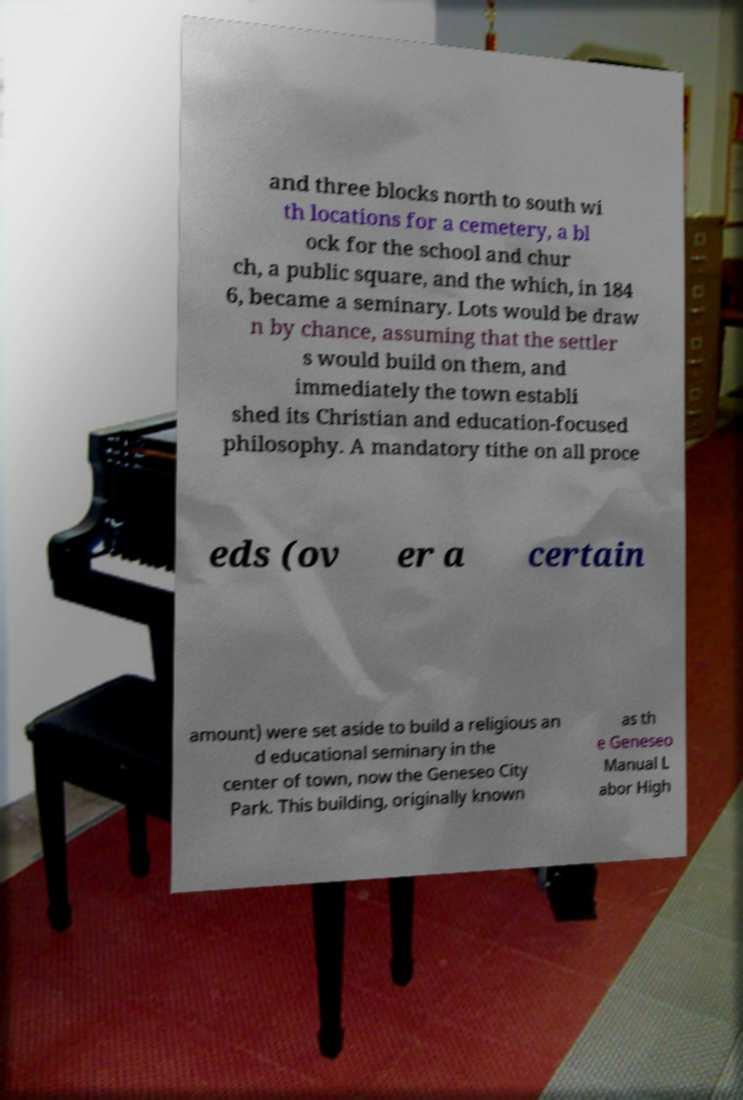Can you accurately transcribe the text from the provided image for me? and three blocks north to south wi th locations for a cemetery, a bl ock for the school and chur ch, a public square, and the which, in 184 6, became a seminary. Lots would be draw n by chance, assuming that the settler s would build on them, and immediately the town establi shed its Christian and education-focused philosophy. A mandatory tithe on all proce eds (ov er a certain amount) were set aside to build a religious an d educational seminary in the center of town, now the Geneseo City Park. This building, originally known as th e Geneseo Manual L abor High 